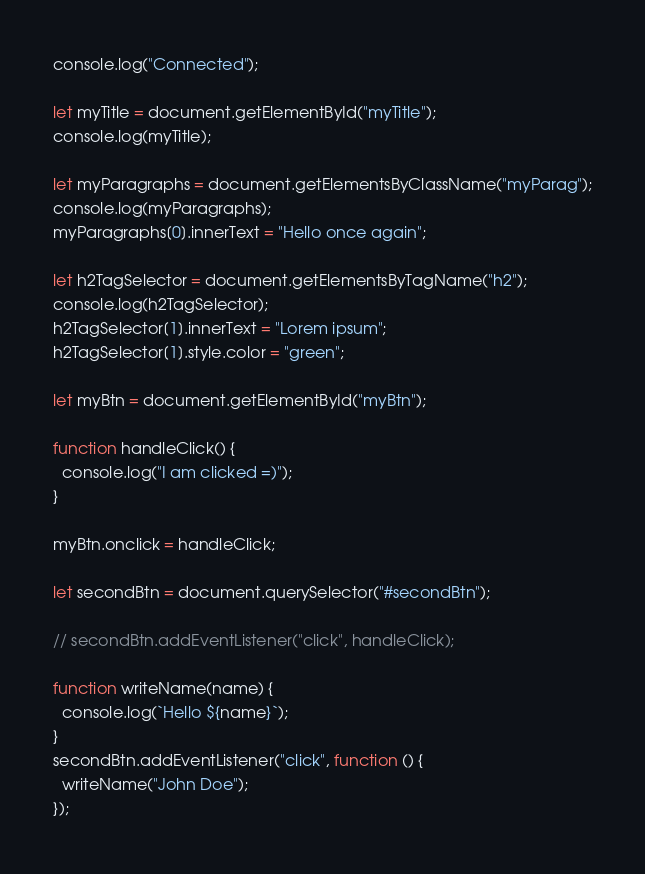Convert code to text. <code><loc_0><loc_0><loc_500><loc_500><_JavaScript_>console.log("Connected");

let myTitle = document.getElementById("myTitle");
console.log(myTitle);

let myParagraphs = document.getElementsByClassName("myParag");
console.log(myParagraphs);
myParagraphs[0].innerText = "Hello once again";

let h2TagSelector = document.getElementsByTagName("h2");
console.log(h2TagSelector);
h2TagSelector[1].innerText = "Lorem ipsum";
h2TagSelector[1].style.color = "green";

let myBtn = document.getElementById("myBtn");

function handleClick() {
  console.log("I am clicked =)");
}

myBtn.onclick = handleClick;

let secondBtn = document.querySelector("#secondBtn");

// secondBtn.addEventListener("click", handleClick);

function writeName(name) {
  console.log(`Hello ${name}`);
}
secondBtn.addEventListener("click", function () {
  writeName("John Doe");
});
</code> 